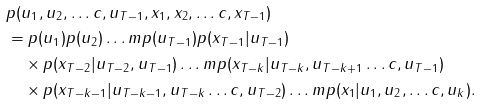Convert formula to latex. <formula><loc_0><loc_0><loc_500><loc_500>& p ( u _ { 1 } , u _ { 2 } , \dots c , u _ { T - 1 } , x _ { 1 } , x _ { 2 } , \dots c , x _ { T - 1 } ) \\ & = p ( u _ { 1 } ) p ( u _ { 2 } ) \dots m p ( u _ { T - 1 } ) p ( x _ { T - 1 } | u _ { T - 1 } ) \\ & \quad \times p ( x _ { T - 2 } | u _ { T - 2 } , u _ { T - 1 } ) \dots m p ( x _ { T - k } | u _ { T - k } , u _ { T - k + 1 } \dots c , u _ { T - 1 } ) \\ & \quad \times p ( x _ { T - k - 1 } | u _ { T - k - 1 } , u _ { T - k } \dots c , u _ { T - 2 } ) \dots m p ( x _ { 1 } | u _ { 1 } , u _ { 2 } , \dots c , u _ { k } ) .</formula> 